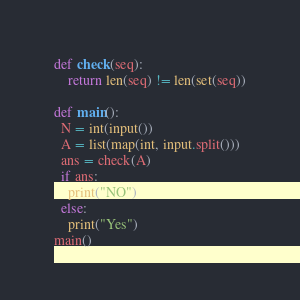Convert code to text. <code><loc_0><loc_0><loc_500><loc_500><_Python_>def check(seq):
    return len(seq) != len(set(seq))

def main():
  N = int(input())
  A = list(map(int, input.split()))
  ans = check(A)
  if ans:
    print("NO")
  else:
    print("Yes")
main()</code> 